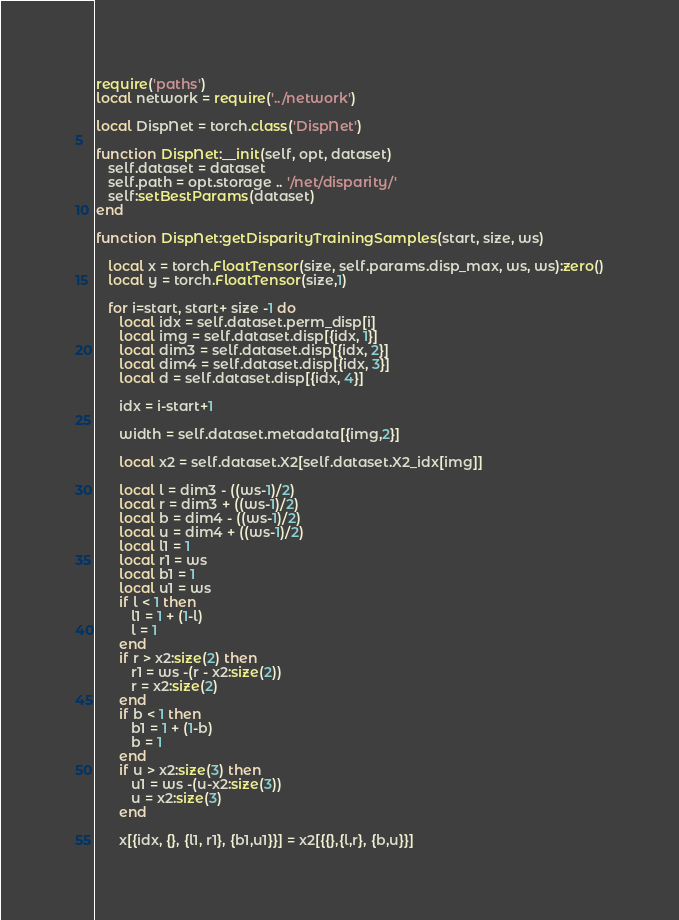Convert code to text. <code><loc_0><loc_0><loc_500><loc_500><_Lua_>require('paths')
local network = require('../network')

local DispNet = torch.class('DispNet')

function DispNet:__init(self, opt, dataset)
   self.dataset = dataset
   self.path = opt.storage .. '/net/disparity/'
   self:setBestParams(dataset)
end

function DispNet:getDisparityTrainingSamples(start, size, ws)

   local x = torch.FloatTensor(size, self.params.disp_max, ws, ws):zero()
   local y = torch.FloatTensor(size,1)

   for i=start, start+ size -1 do
      local idx = self.dataset.perm_disp[i]
      local img = self.dataset.disp[{idx, 1}]
      local dim3 = self.dataset.disp[{idx, 2}]
      local dim4 = self.dataset.disp[{idx, 3}]
      local d = self.dataset.disp[{idx, 4}]

      idx = i-start+1

      width = self.dataset.metadata[{img,2}]

      local x2 = self.dataset.X2[self.dataset.X2_idx[img]]

      local l = dim3 - ((ws-1)/2)
      local r = dim3 + ((ws-1)/2)
      local b = dim4 - ((ws-1)/2)
      local u = dim4 + ((ws-1)/2)
      local l1 = 1
      local r1 = ws
      local b1 = 1
      local u1 = ws
      if l < 1 then
         l1 = 1 + (1-l)
         l = 1
      end
      if r > x2:size(2) then
         r1 = ws -(r - x2:size(2))
         r = x2:size(2)
      end
      if b < 1 then
         b1 = 1 + (1-b)
         b = 1
      end
      if u > x2:size(3) then
         u1 = ws -(u-x2:size(3))
         u = x2:size(3)
      end

      x[{idx, {}, {l1, r1}, {b1,u1}}] = x2[{{},{l,r}, {b,u}}]</code> 